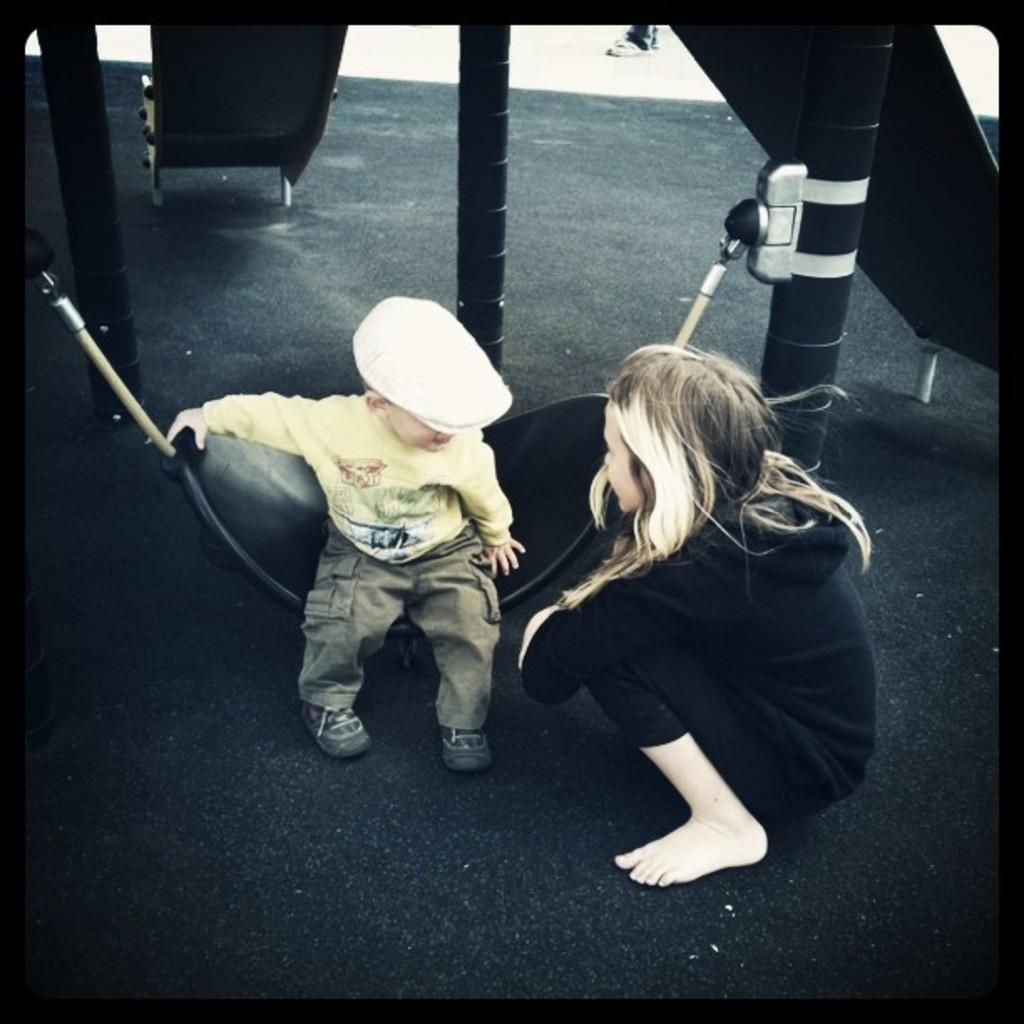What is the main subject of the image? There is a child in the image. What is the child wearing? The child is wearing a cap. What is the child doing in the image? The child is sitting on a swing. Are there any other people in the image? Yes, there is a girl in the image. What can be seen in the background of the image? There are poles and a chair in the background of the image. What type of government is depicted in the image? There is no depiction of a government in the image; it features a child sitting on a swing. What act is the child performing on the swing? The image does not show the child performing any specific act on the swing; they are simply sitting on it. 